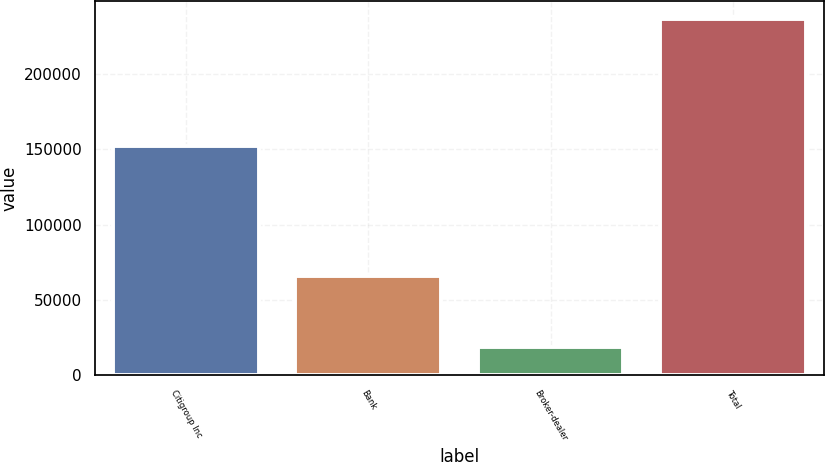Convert chart to OTSL. <chart><loc_0><loc_0><loc_500><loc_500><bar_chart><fcel>Citigroup Inc<fcel>Bank<fcel>Broker-dealer<fcel>Total<nl><fcel>152163<fcel>65856<fcel>18690<fcel>236709<nl></chart> 